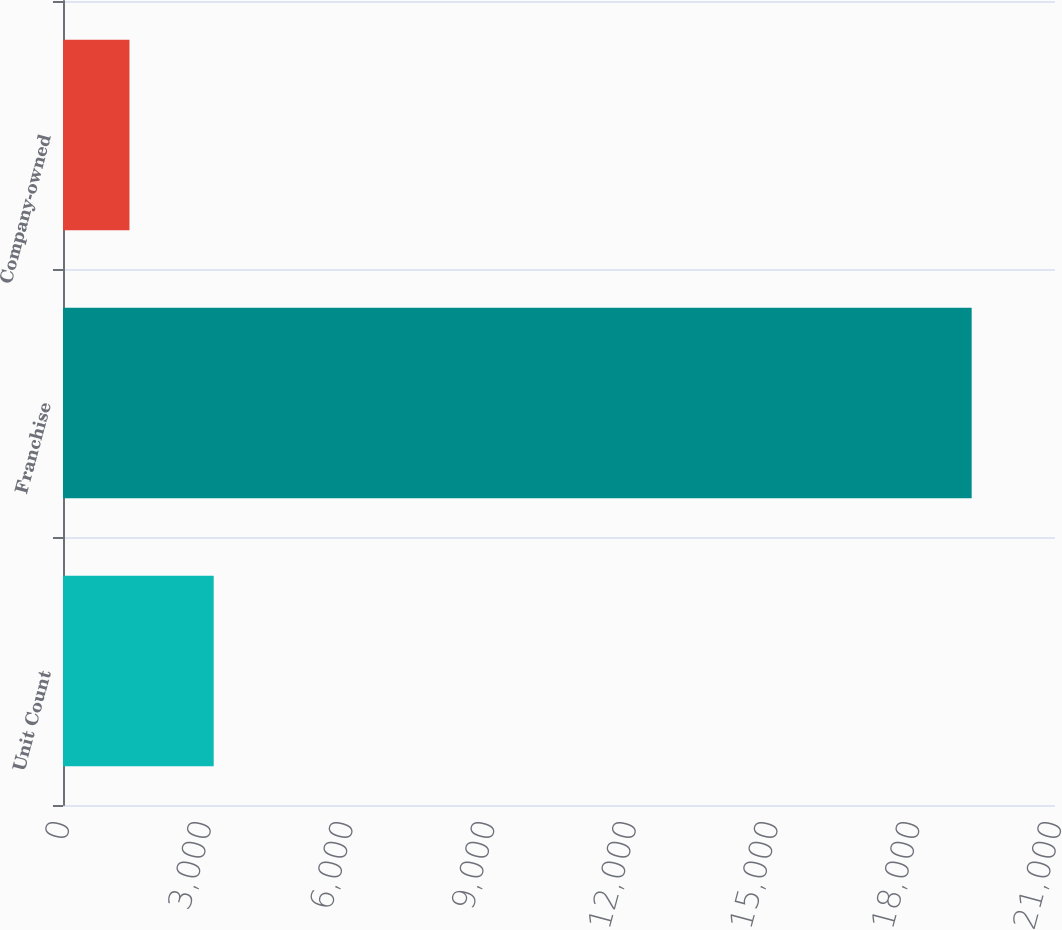Convert chart. <chart><loc_0><loc_0><loc_500><loc_500><bar_chart><fcel>Unit Count<fcel>Franchise<fcel>Company-owned<nl><fcel>3189.9<fcel>19236<fcel>1407<nl></chart> 